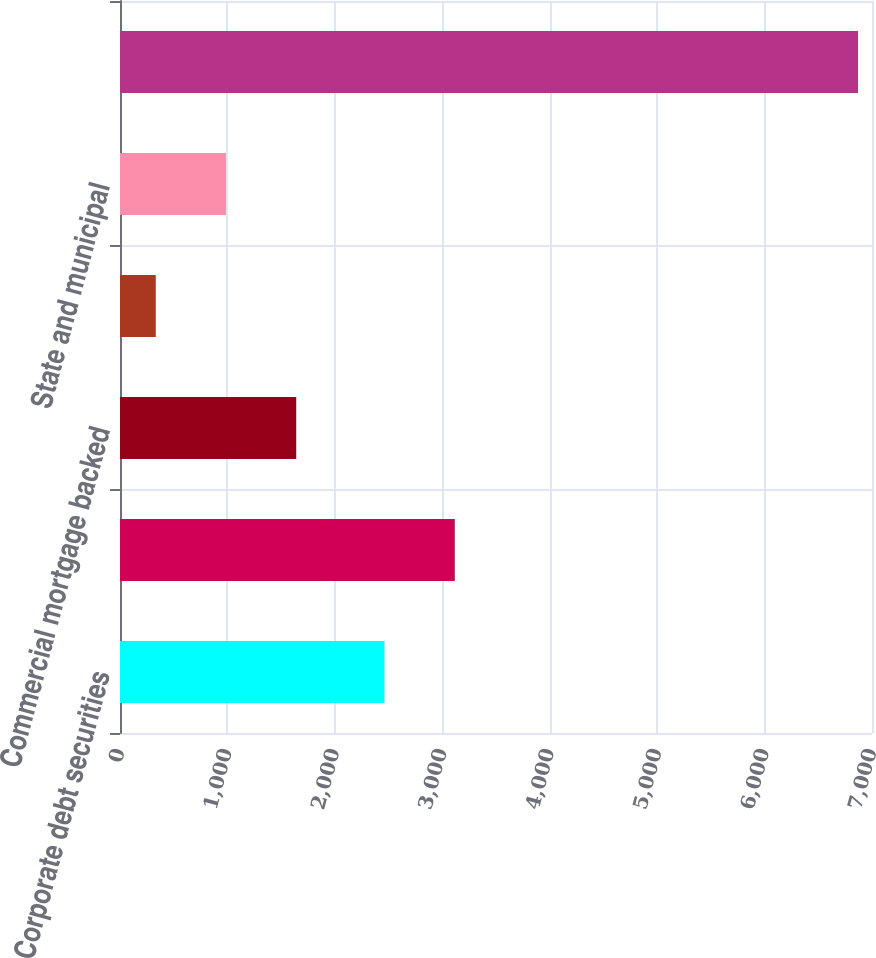Convert chart to OTSL. <chart><loc_0><loc_0><loc_500><loc_500><bar_chart><fcel>Corporate debt securities<fcel>Residential mortgage backed<fcel>Commercial mortgage backed<fcel>Asset backed securities<fcel>State and municipal<fcel>Total<nl><fcel>2463<fcel>3116.7<fcel>1640.4<fcel>333<fcel>986.7<fcel>6870<nl></chart> 